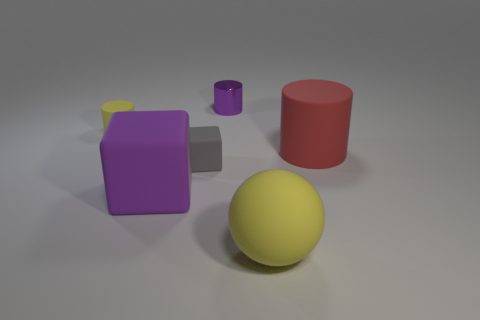Add 2 large purple shiny blocks. How many objects exist? 8 Subtract all spheres. How many objects are left? 5 Subtract 0 cyan cylinders. How many objects are left? 6 Subtract all large red cubes. Subtract all small purple shiny cylinders. How many objects are left? 5 Add 2 yellow matte cylinders. How many yellow matte cylinders are left? 3 Add 5 tiny yellow metal spheres. How many tiny yellow metal spheres exist? 5 